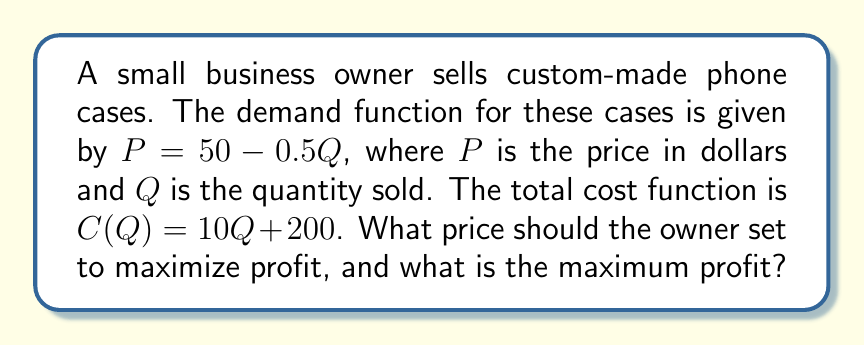Give your solution to this math problem. To determine the optimal pricing strategy, we'll use the profit maximization formula:

1) First, let's define the profit function:
   $\Pi(Q) = TR(Q) - TC(Q)$, where $\Pi$ is profit, $TR$ is total revenue, and $TC$ is total cost.

2) Total revenue is price times quantity:
   $TR(Q) = PQ = (50 - 0.5Q)Q = 50Q - 0.5Q^2$

3) We're given the total cost function:
   $TC(Q) = 10Q + 200$

4) Now, let's write out the profit function:
   $\Pi(Q) = TR(Q) - TC(Q) = (50Q - 0.5Q^2) - (10Q + 200) = 40Q - 0.5Q^2 - 200$

5) To maximize profit, we find where the derivative of the profit function equals zero:
   $\frac{d\Pi}{dQ} = 40 - Q = 0$

6) Solving this equation:
   $40 - Q = 0$
   $Q = 40$

7) This gives us the optimal quantity. To find the optimal price, we plug this back into our demand function:
   $P = 50 - 0.5(40) = 50 - 20 = 30$

8) To calculate the maximum profit, we plug $Q = 40$ into our profit function:
   $\Pi(40) = 40(40) - 0.5(40)^2 - 200 = 1600 - 800 - 200 = 600$

Therefore, the optimal price is $30, and the maximum profit is $600.
Answer: Optimal price: $30; Maximum profit: $600 